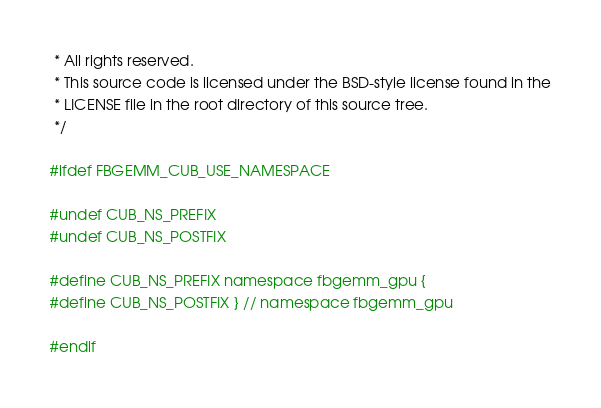Convert code to text. <code><loc_0><loc_0><loc_500><loc_500><_Cuda_> * All rights reserved.
 * This source code is licensed under the BSD-style license found in the
 * LICENSE file in the root directory of this source tree.
 */

#ifdef FBGEMM_CUB_USE_NAMESPACE

#undef CUB_NS_PREFIX
#undef CUB_NS_POSTFIX

#define CUB_NS_PREFIX namespace fbgemm_gpu {
#define CUB_NS_POSTFIX } // namespace fbgemm_gpu

#endif
</code> 